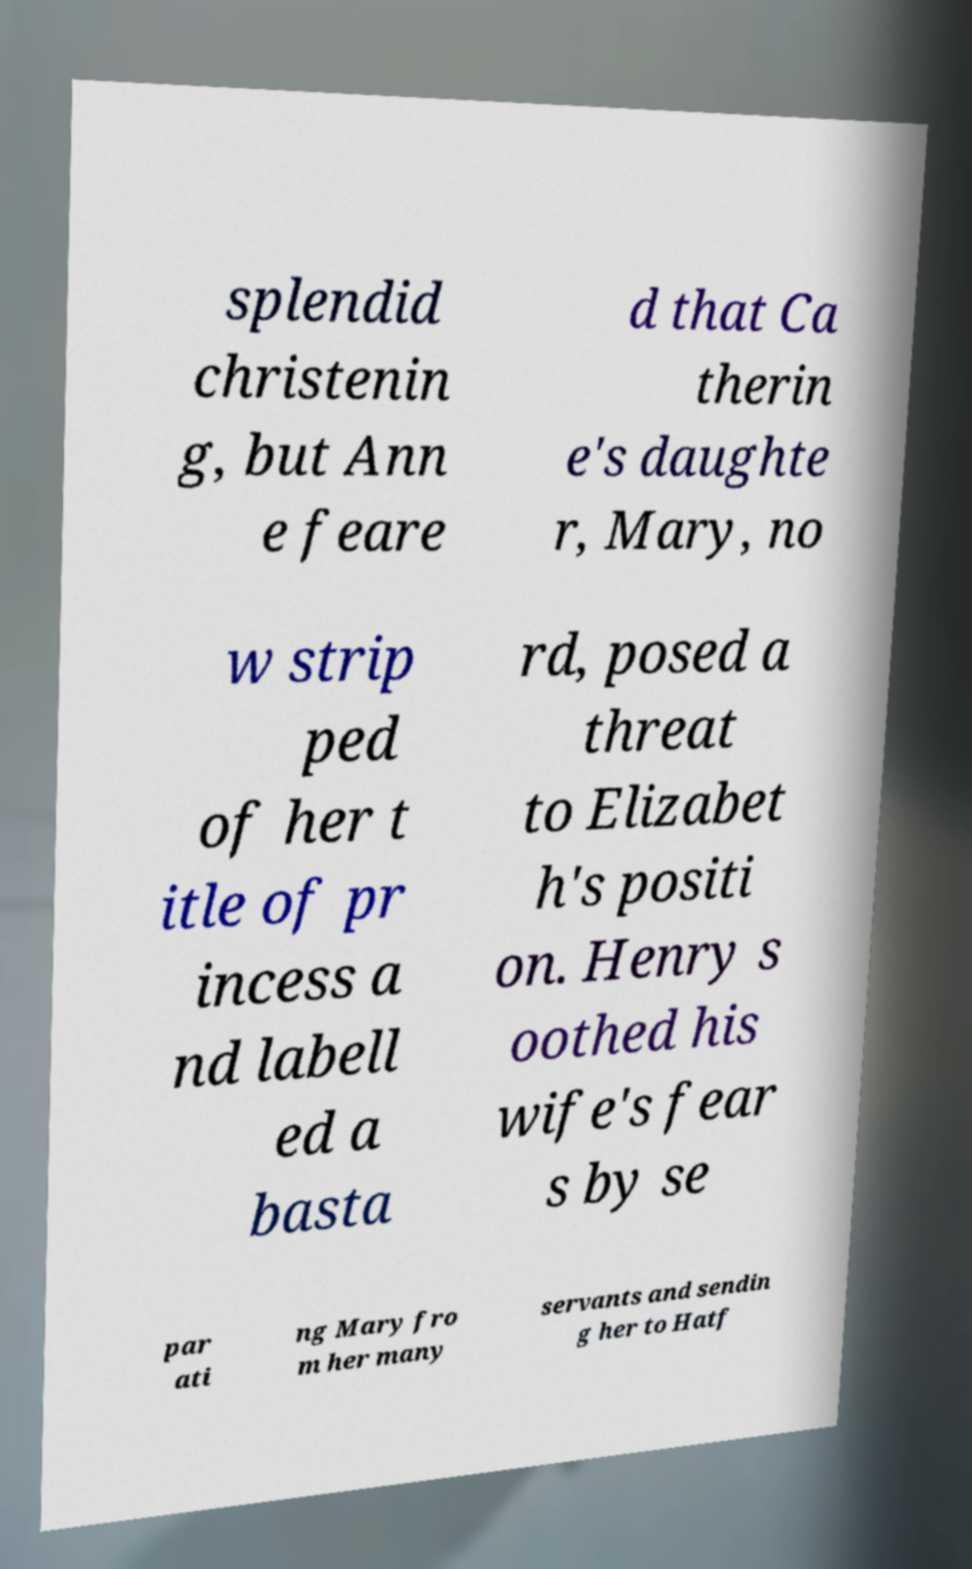Could you extract and type out the text from this image? splendid christenin g, but Ann e feare d that Ca therin e's daughte r, Mary, no w strip ped of her t itle of pr incess a nd labell ed a basta rd, posed a threat to Elizabet h's positi on. Henry s oothed his wife's fear s by se par ati ng Mary fro m her many servants and sendin g her to Hatf 